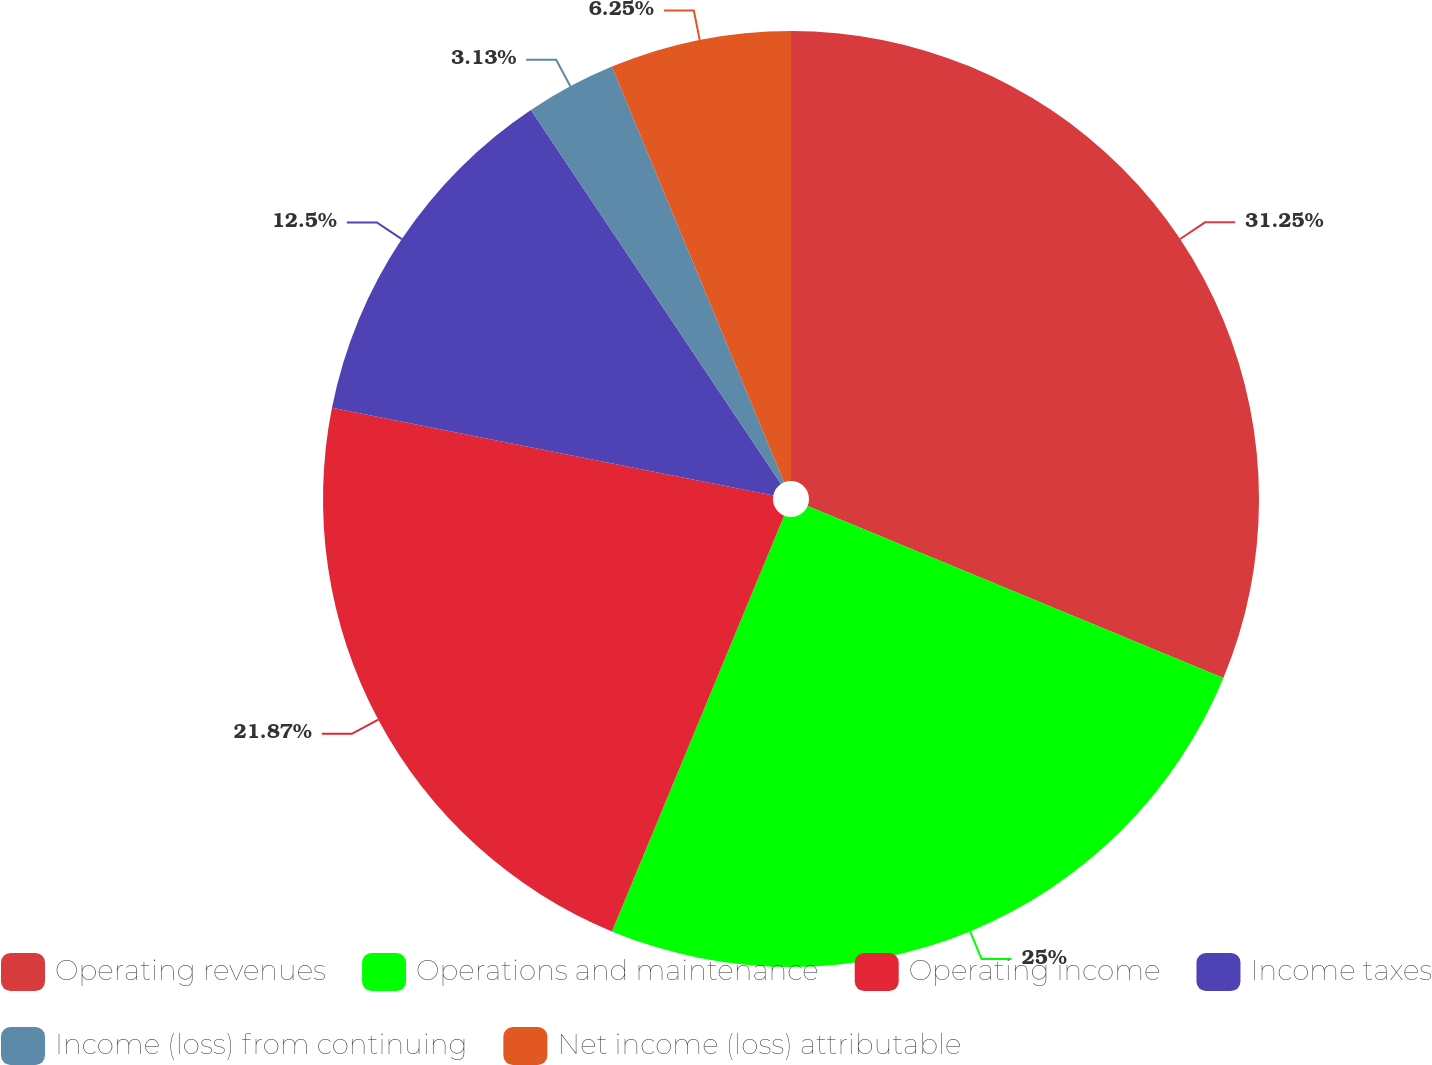Convert chart to OTSL. <chart><loc_0><loc_0><loc_500><loc_500><pie_chart><fcel>Operating revenues<fcel>Operations and maintenance<fcel>Operating income<fcel>Income taxes<fcel>Income (loss) from continuing<fcel>Net income (loss) attributable<nl><fcel>31.25%<fcel>25.0%<fcel>21.87%<fcel>12.5%<fcel>3.13%<fcel>6.25%<nl></chart> 